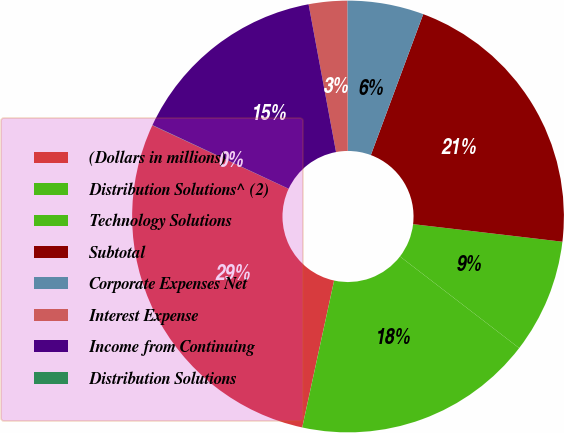Convert chart. <chart><loc_0><loc_0><loc_500><loc_500><pie_chart><fcel>(Dollars in millions)<fcel>Distribution Solutions^ (2)<fcel>Technology Solutions<fcel>Subtotal<fcel>Corporate Expenses Net<fcel>Interest Expense<fcel>Income from Continuing<fcel>Distribution Solutions<nl><fcel>28.54%<fcel>17.97%<fcel>8.57%<fcel>21.2%<fcel>5.72%<fcel>2.87%<fcel>15.12%<fcel>0.02%<nl></chart> 